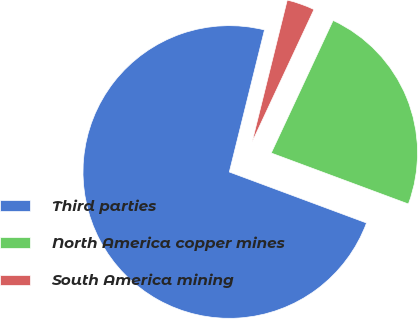Convert chart. <chart><loc_0><loc_0><loc_500><loc_500><pie_chart><fcel>Third parties<fcel>North America copper mines<fcel>South America mining<nl><fcel>73.2%<fcel>23.71%<fcel>3.09%<nl></chart> 